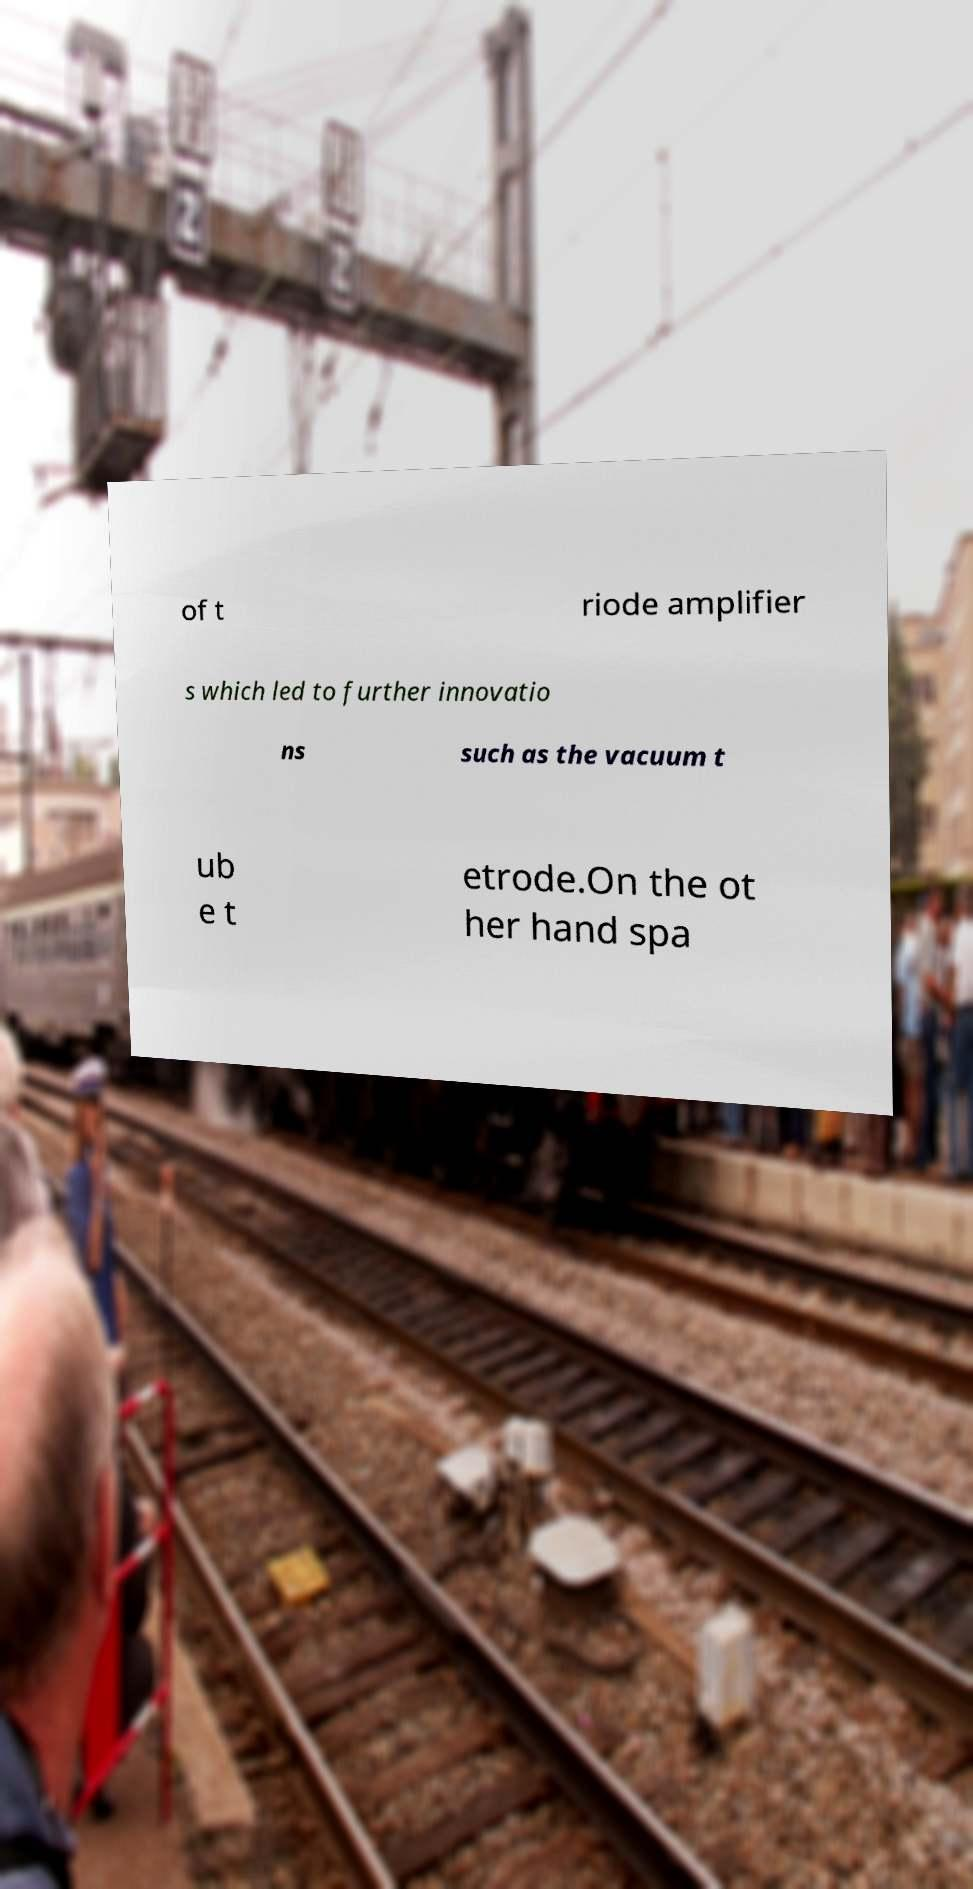Please read and relay the text visible in this image. What does it say? of t riode amplifier s which led to further innovatio ns such as the vacuum t ub e t etrode.On the ot her hand spa 